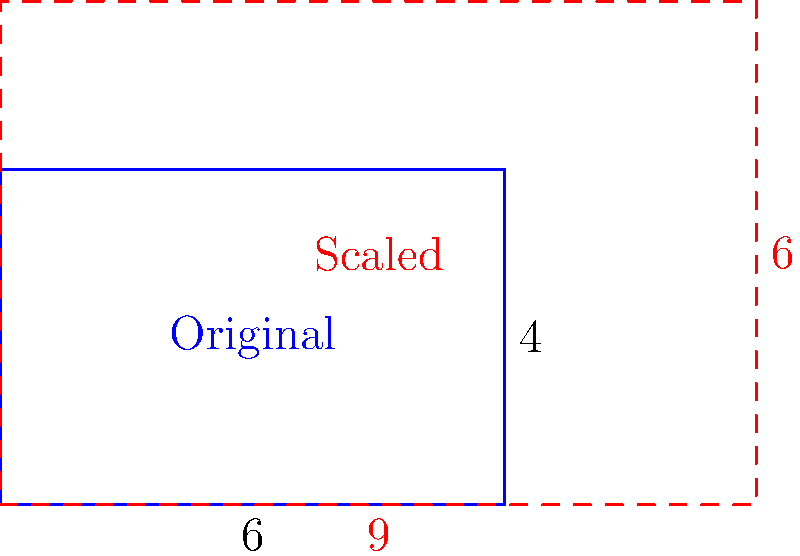The proposed community center blueprint is being scaled up for a larger population. If the original dimensions were 6 units by 4 units and the new width is 9 units, what is the new height to maintain the same proportions? To solve this problem, we need to use the concept of scaling in transformational geometry. Here's a step-by-step explanation:

1) First, let's identify the scale factor. We can do this by comparing the new width to the original width:
   Scale factor = New width / Original width = $9 / 6 = 1.5$

2) In scaling, all dimensions are multiplied by the same scale factor to maintain proportions.

3) To find the new height, we multiply the original height by the scale factor:
   New height = Original height × Scale factor
               = $4 × 1.5 = 6$

4) We can verify this result by checking if the ratio of width to height remains the same:
   Original ratio: $6:4 = 1.5:1$
   New ratio: $9:6 = 1.5:1$

Therefore, the new height of the scaled community center blueprint is 6 units.
Answer: 6 units 